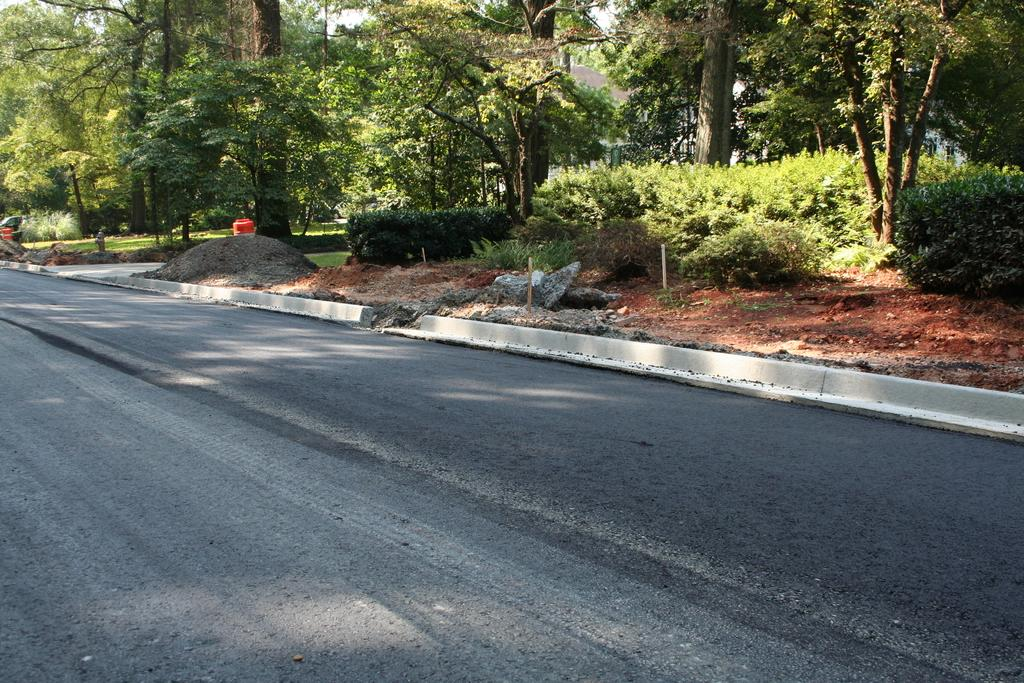What is the main feature of the image? There is a road in the image. What type of natural elements can be seen in the image? Trees and plants are visible in the image. What type of spot can be seen on the road in the image? There is no spot visible on the road in the image. 